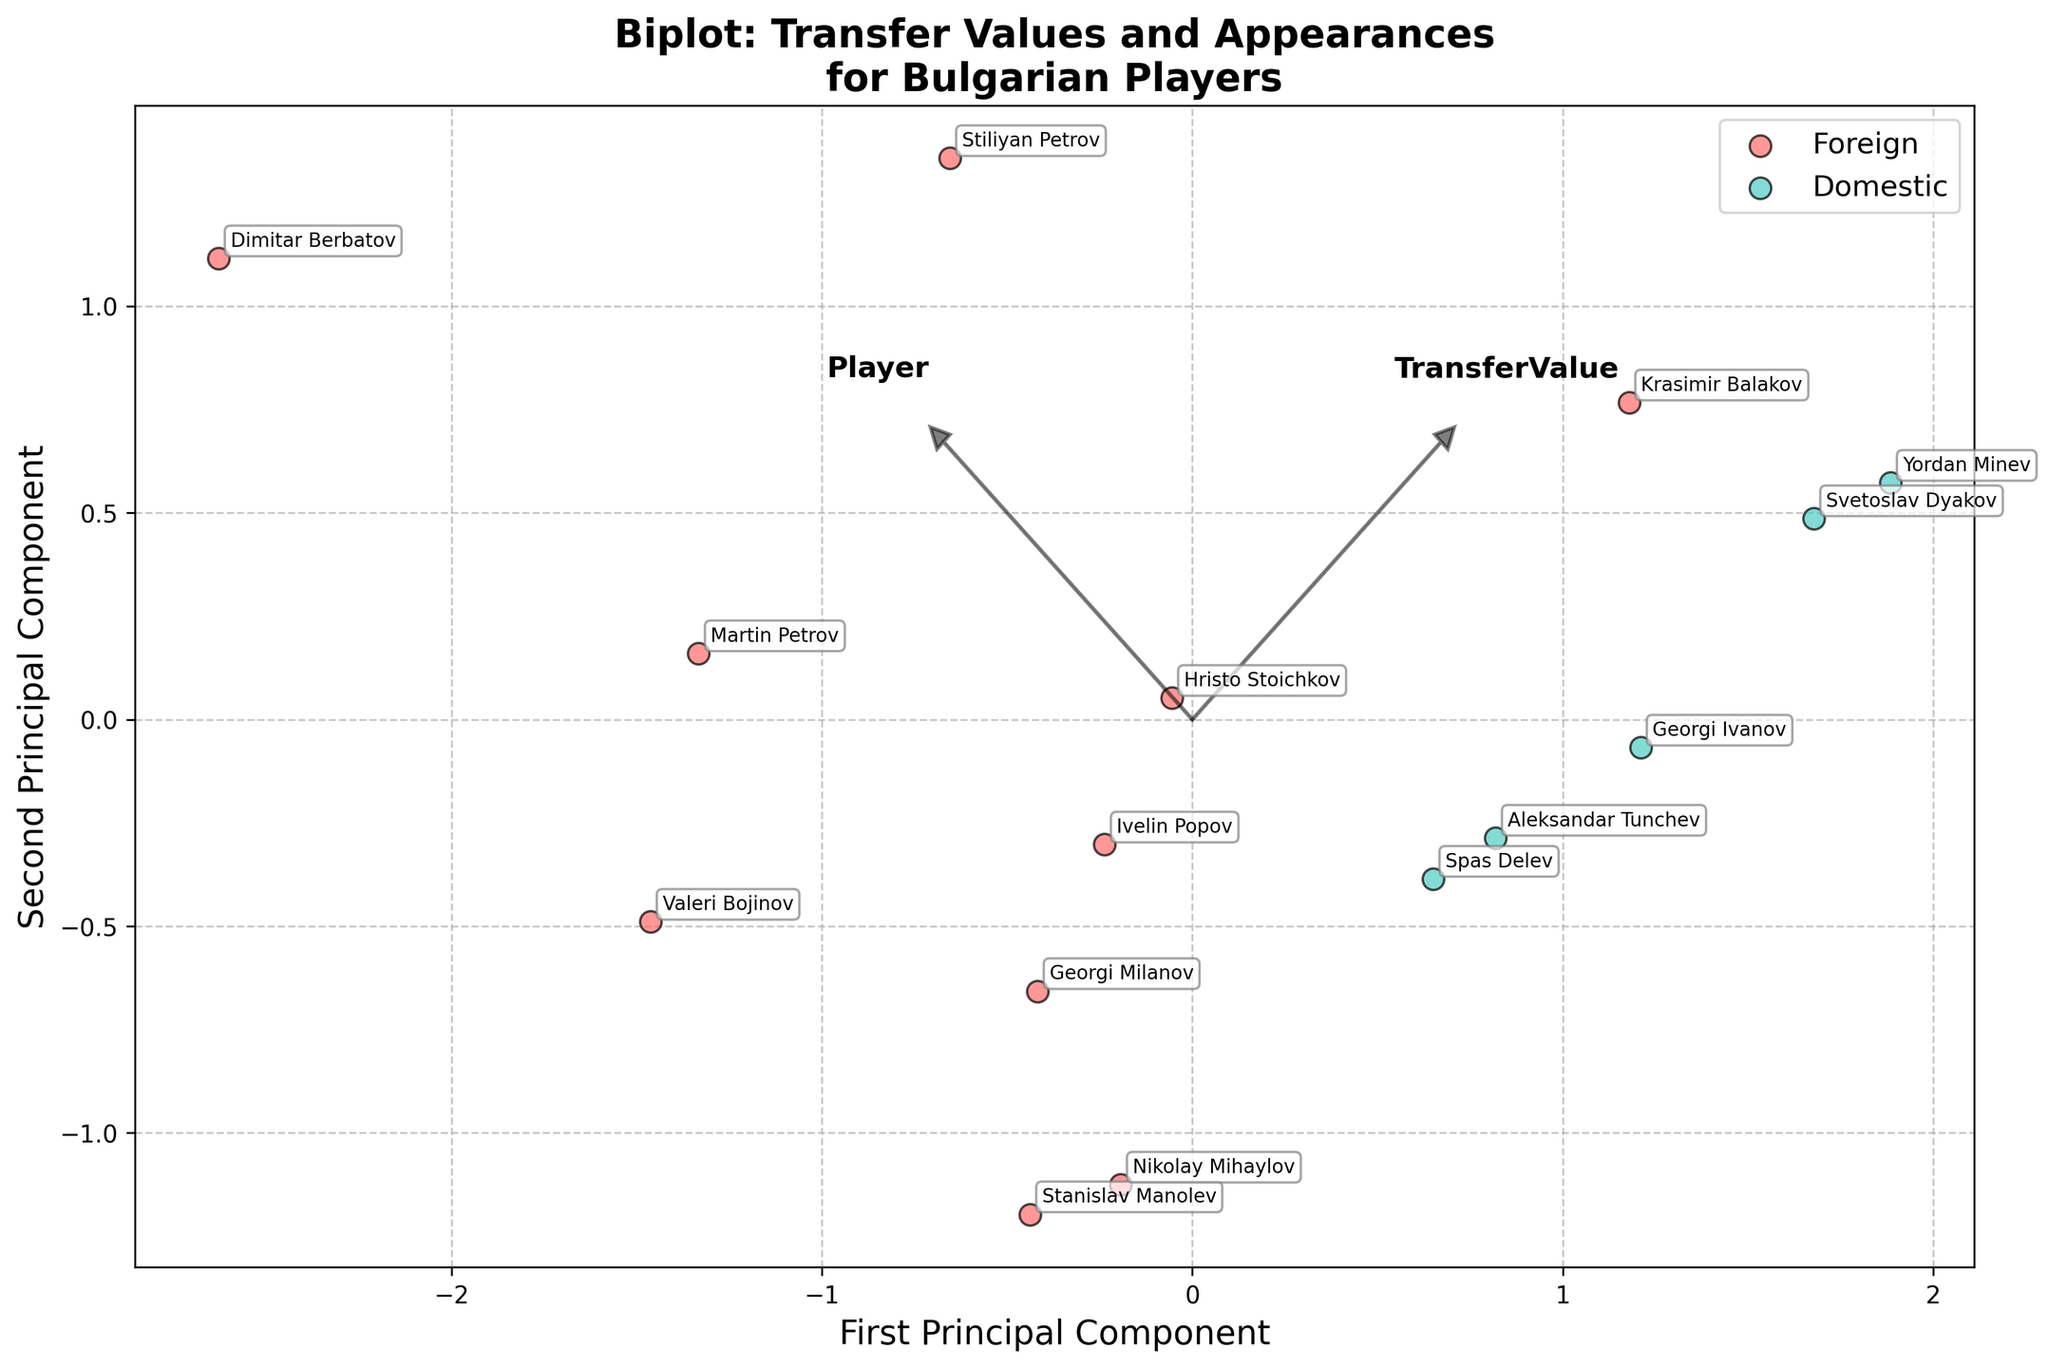what is the title of the figure? The title of the figure is displayed at the top and summarizes the main topic of the plot, which in this case is about the transfer values and appearances of Bulgarian players.
Answer: Biplot: Transfer Values and Appearances for Bulgarian Players how are the players categorized in the plot? The players in the plot are categorized based on their league type, which can be either "Foreign" or "Domestic". This categorization is visually represented by different colors: red for Foreign and green for Domestic.
Answer: By league type (Foreign and Domestic) how many players belong to the 'foreign' league type? The biplot uses colors to represent different league types. By counting the data points marked in red, one can determine the number of foreign league players.
Answer: 10 which player has the highest transfer value? The player's transfer value is indicated by their position on the plot. The player with the highest transfer value will be positioned furthest in the direction of the "TransferValue" vector.
Answer: Dimitar Berbatov how do the appearances of foreign players generally compare to those of domestic players? By observing the clustering of data points representing foreign and domestic players along the "Appearances" vector, one can see that domestic players have a wider range of appearances, with some having very high counts, while foreign players tend to have moderate to high appearances.
Answer: Domestic players generally have more appearances which foreign player has the highest number of appearances? By examining the position of foreign players along the "Appearances" vector, the player furthest in this direction will have the highest number of appearances.
Answer: Stiliyan Petrov who has the lowest transfer value among all players represented? The player with the lowest transfer value will be closest to the origin along the "TransferValue" vector.
Answer: Yordan Minev which player has a transfer value of 8500000 and how many appearances do they have? To determine this, locate the player along the "TransferValue" vector at the value of 8500000 and read off the corresponding number of appearances based on their position.
Answer: Martin Petrov, 108 appearances is there a correlation between transfer value and appearances for domestic players? To determine the correlation, one can observe the spread of domestic players along the directions of both vectors ("TransferValue" and "Appearances"). If there is a trend where higher appearances correspond to higher transfer values (or vice versa), it indicates a correlation.
Answer: No strong correlation which player is closest to the origin and what does it signify about their transfer value and appearances? The player closest to the origin has relatively lower values of both transfer value and appearances compared to others. This is because the origin represents the mean values of the standardized data.
Answer: Georgi Ivanov 